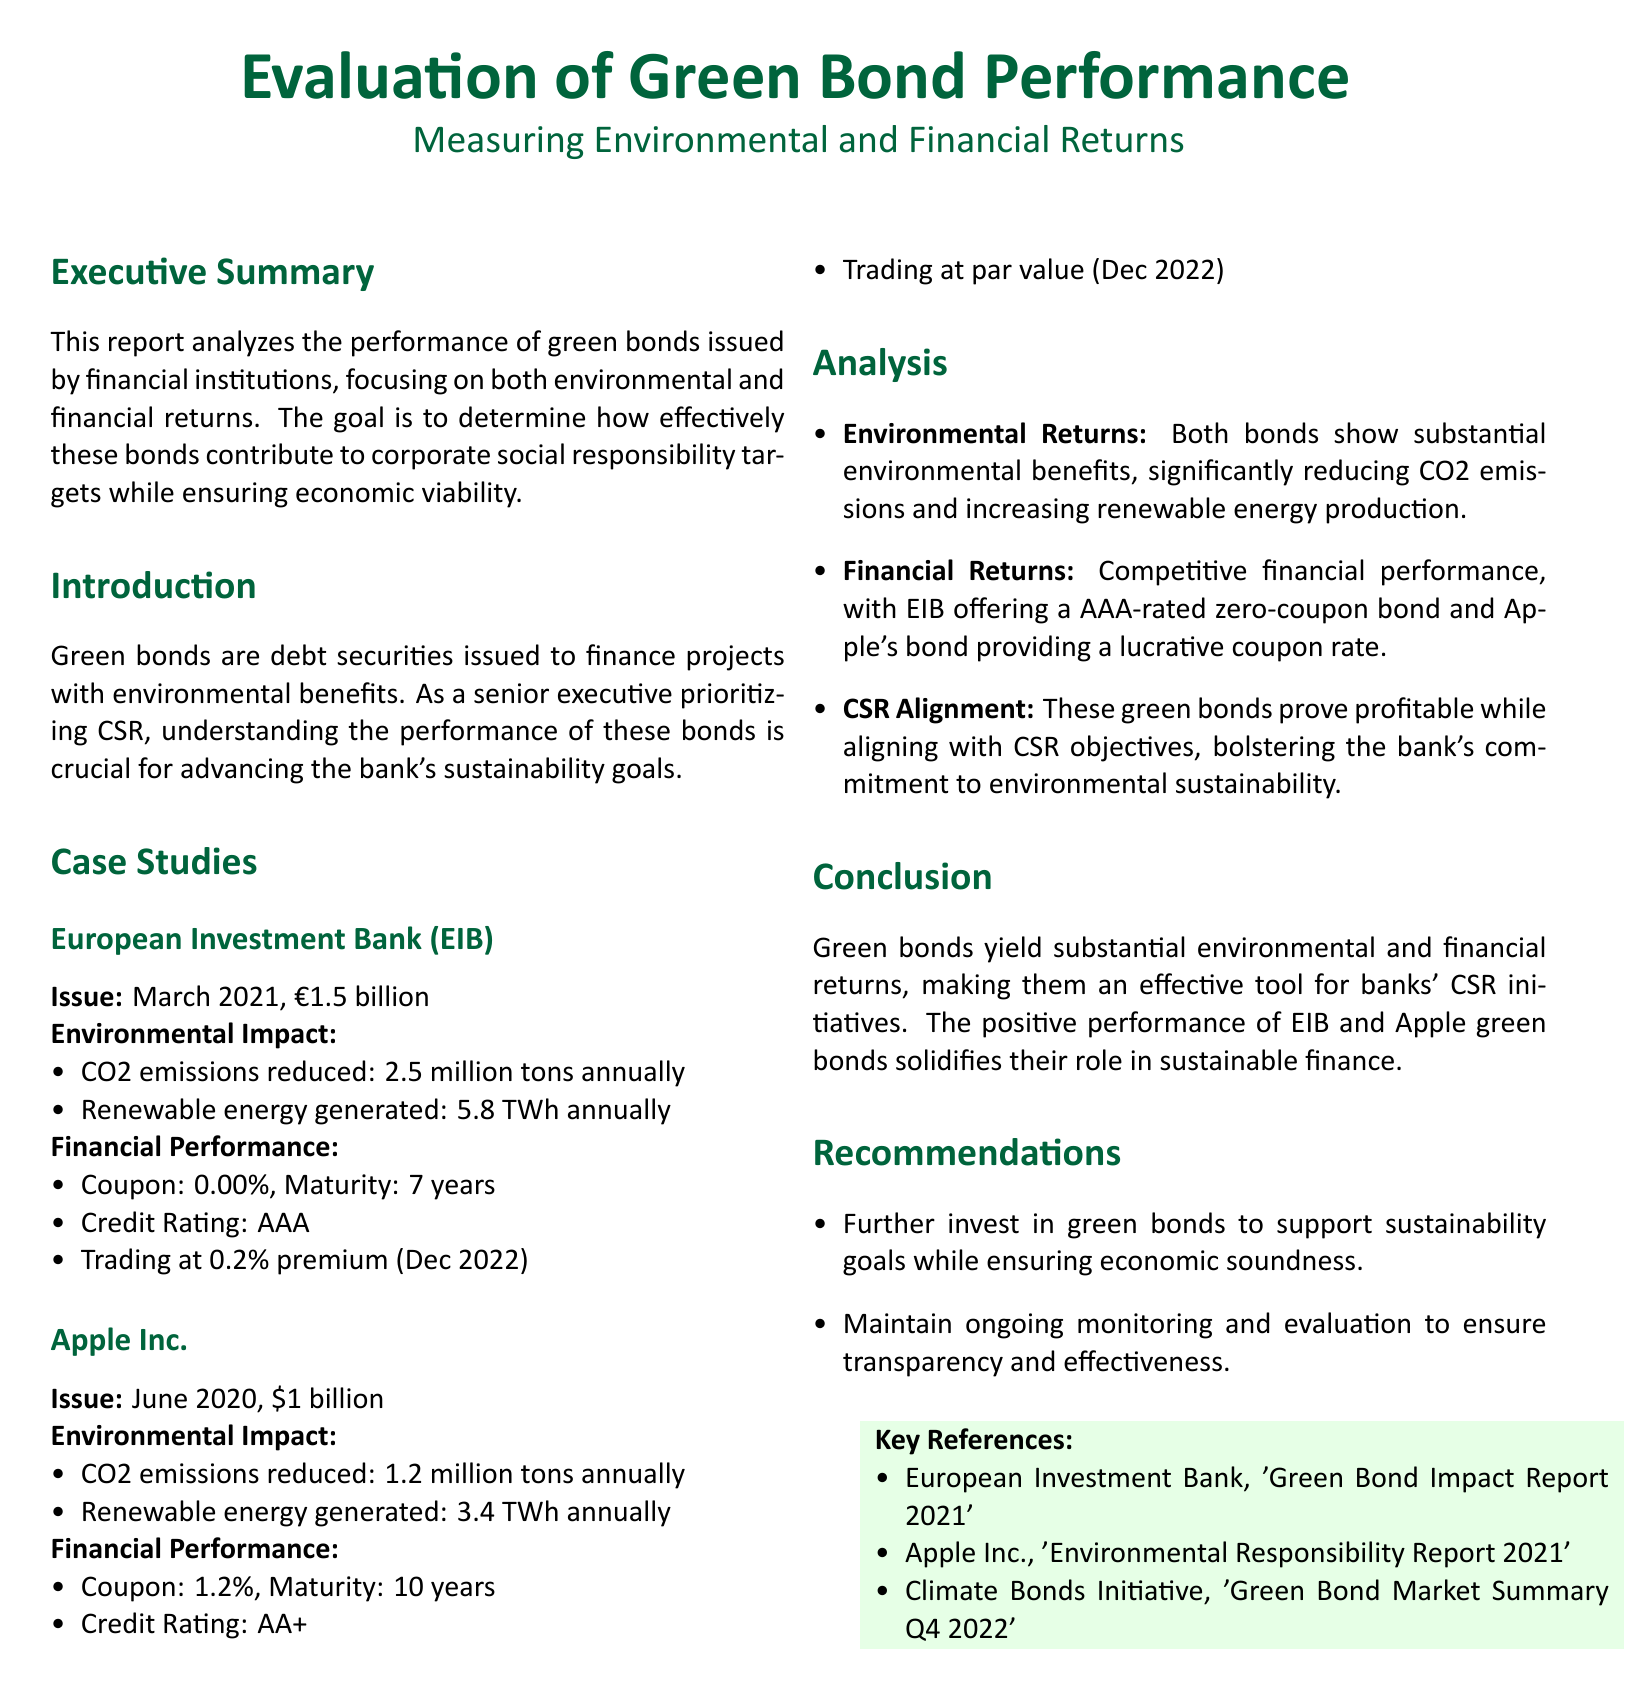What is the issue date of the European Investment Bank green bond? The issue date is provided in the case study of the European Investment Bank section.
Answer: March 2021 How much CO2 emissions does the Apple Inc. green bond reduce annually? The annual CO2 emissions reduction is specified in the case study of Apple Inc.
Answer: 1.2 million tons What is the maturity period of the EIB green bond? The maturity period is listed under the financial performance section for the EIB green bond.
Answer: 7 years What is the coupon rate of Apple's green bond? The coupon rate is mentioned in the financial performance section of the Apple Inc. case study.
Answer: 1.2% What environmental benefit does the EIB green bond generate annually? The document specifies the renewable energy generated annually by the EIB bond.
Answer: 5.8 TWh Which credit rating is given to the EIB green bond? The credit rating can be found in the financial performance section of the EIB case study.
Answer: AAA What is the primary goal of the report according to the executive summary? The goal is detailed in the executive summary, focusing on the effective contribution to CSR targets.
Answer: Corporate social responsibility What two key areas are analyzed in the report? The analysis section highlights the areas of focus in the report.
Answer: Environmental returns and financial returns What is one recommendation made in the report? Recommendations are listed at the end of the document; one is specifically about investing in green bonds.
Answer: Further invest in green bonds 